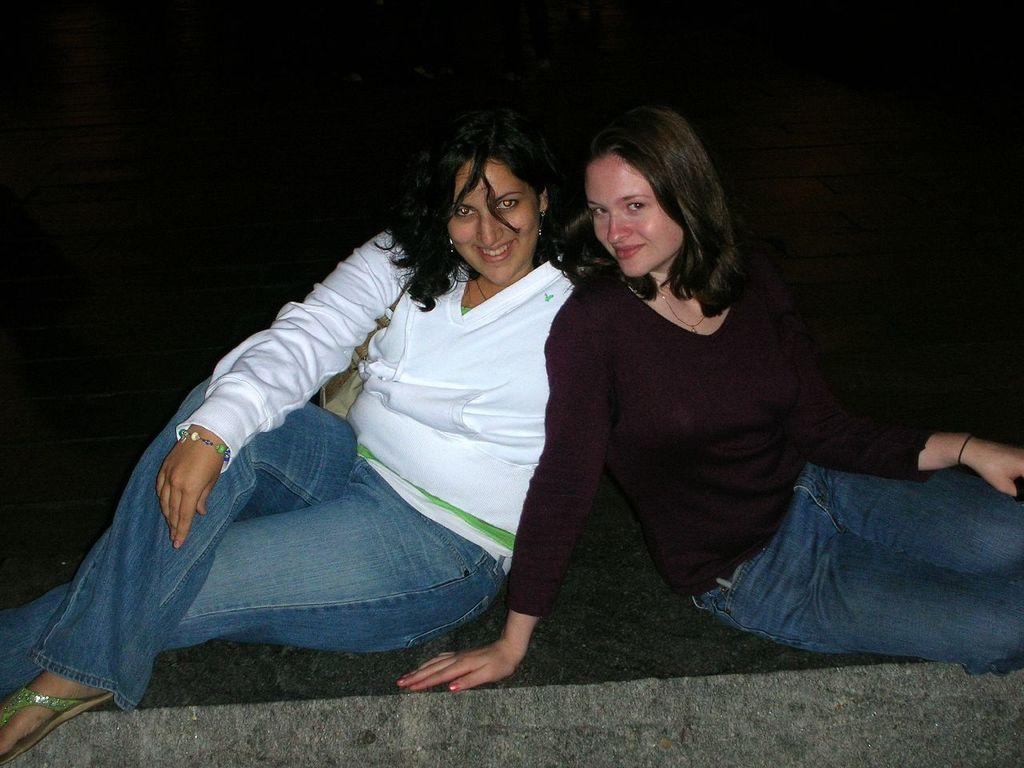How many people are in the image? There are two women in the image. What are the women doing in the image? The women are smiling in the image. Where are the women sitting in the image? The women are sitting on the floor in the image. What can be observed about the background of the image? The background of the image has a dark view. What type of card is being held by one of the women in the image? There is no card present in the image. What does the caption say that is written on the image? There is no caption written on the image. 